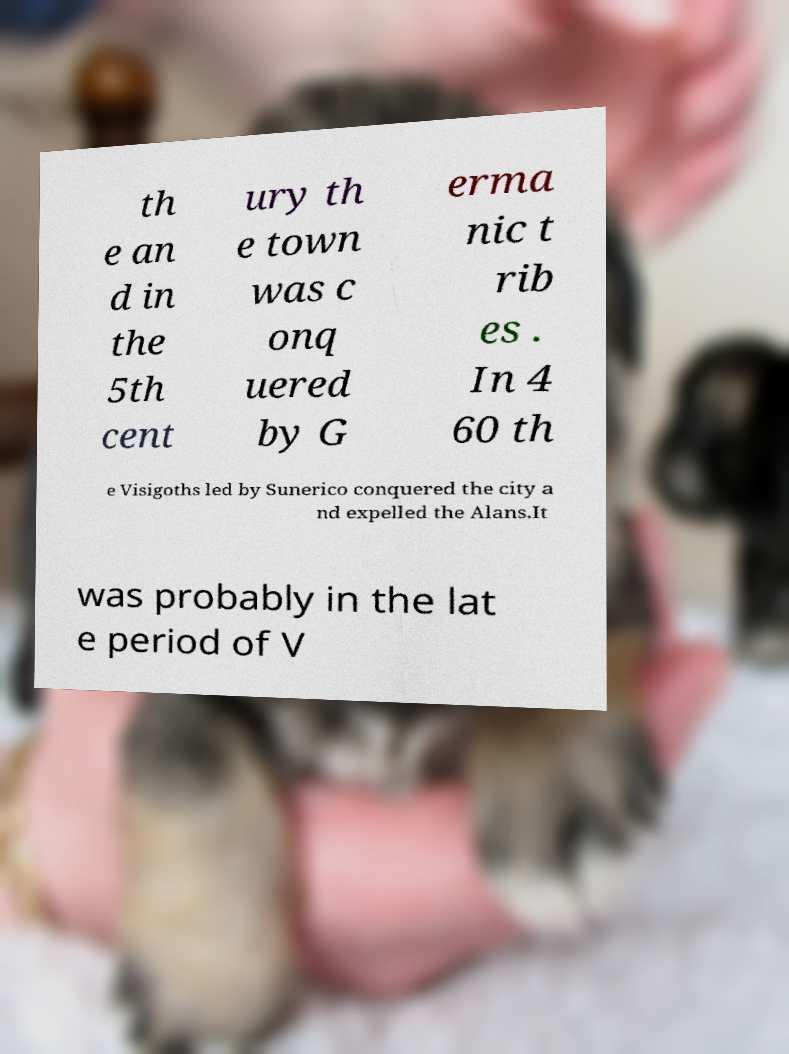Please read and relay the text visible in this image. What does it say? th e an d in the 5th cent ury th e town was c onq uered by G erma nic t rib es . In 4 60 th e Visigoths led by Sunerico conquered the city a nd expelled the Alans.It was probably in the lat e period of V 